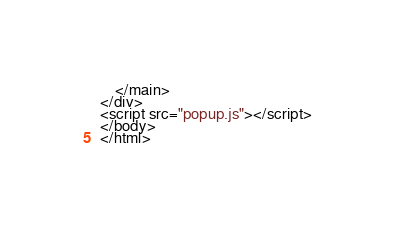<code> <loc_0><loc_0><loc_500><loc_500><_HTML_>    </main>
</div>
<script src="popup.js"></script>
</body>
</html>
</code> 